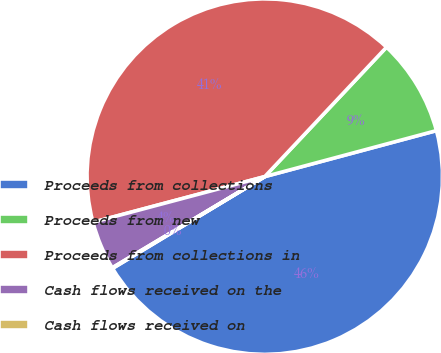Convert chart. <chart><loc_0><loc_0><loc_500><loc_500><pie_chart><fcel>Proceeds from collections<fcel>Proceeds from new<fcel>Proceeds from collections in<fcel>Cash flows received on the<fcel>Cash flows received on<nl><fcel>45.53%<fcel>8.82%<fcel>41.15%<fcel>4.44%<fcel>0.06%<nl></chart> 